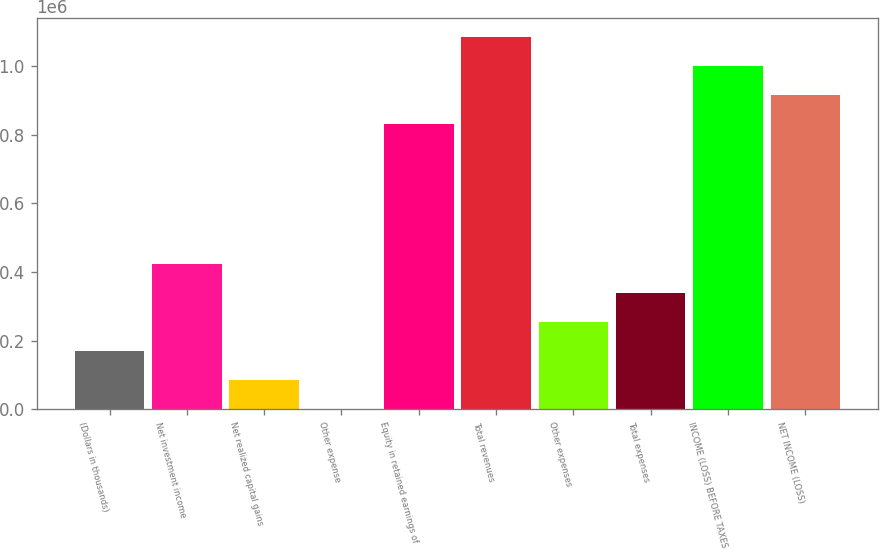Convert chart. <chart><loc_0><loc_0><loc_500><loc_500><bar_chart><fcel>(Dollars in thousands)<fcel>Net investment income<fcel>Net realized capital gains<fcel>Other expense<fcel>Equity in retained earnings of<fcel>Total revenues<fcel>Other expenses<fcel>Total expenses<fcel>INCOME (LOSS) BEFORE TAXES<fcel>NET INCOME (LOSS)<nl><fcel>169674<fcel>423842<fcel>84950.9<fcel>228<fcel>830604<fcel>1.08477e+06<fcel>254397<fcel>339120<fcel>1.00005e+06<fcel>915327<nl></chart> 